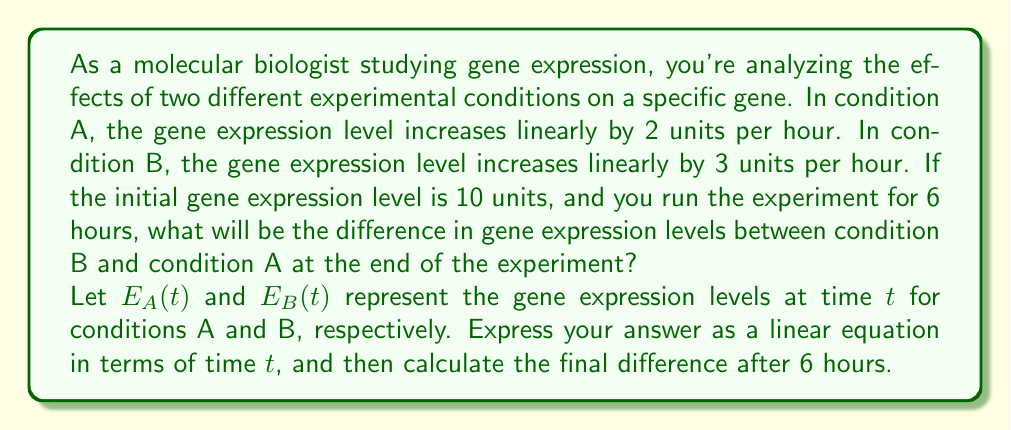Show me your answer to this math problem. To solve this problem, we need to follow these steps:

1. Express the gene expression levels for each condition as a function of time:

   For condition A: $E_A(t) = 10 + 2t$
   For condition B: $E_B(t) = 10 + 3t$

   Where 10 is the initial expression level, and $t$ is the time in hours.

2. Find the difference between the two conditions:

   $\Delta E(t) = E_B(t) - E_A(t)$
   $\Delta E(t) = (10 + 3t) - (10 + 2t)$
   $\Delta E(t) = 3t - 2t$
   $\Delta E(t) = t$

3. Calculate the difference after 6 hours:

   $\Delta E(6) = 6$

The linear equation showing the difference in gene expression levels between condition B and condition A is $\Delta E(t) = t$. This means the difference increases by 1 unit per hour.

After 6 hours, the difference will be 6 units.
Answer: The difference in gene expression levels between condition B and condition A can be expressed as $\Delta E(t) = t$. After 6 hours, the difference will be 6 units. 